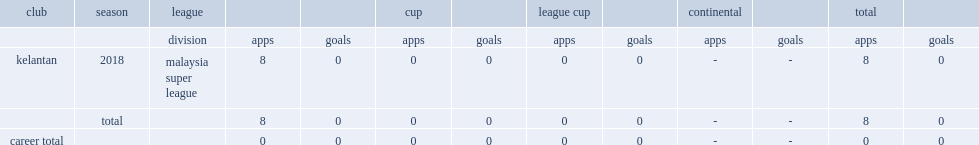Which club did duyshobekov play for in 2018? Kelantan. 